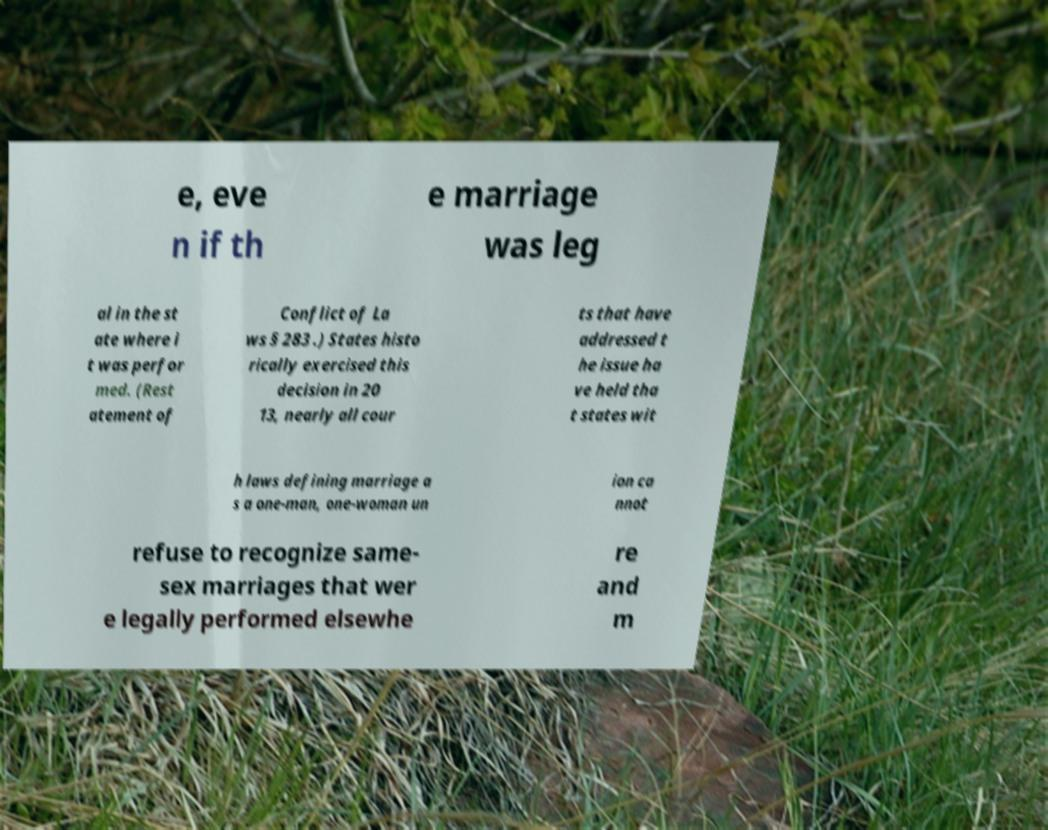There's text embedded in this image that I need extracted. Can you transcribe it verbatim? e, eve n if th e marriage was leg al in the st ate where i t was perfor med. (Rest atement of Conflict of La ws § 283 .) States histo rically exercised this decision in 20 13, nearly all cour ts that have addressed t he issue ha ve held tha t states wit h laws defining marriage a s a one-man, one-woman un ion ca nnot refuse to recognize same- sex marriages that wer e legally performed elsewhe re and m 